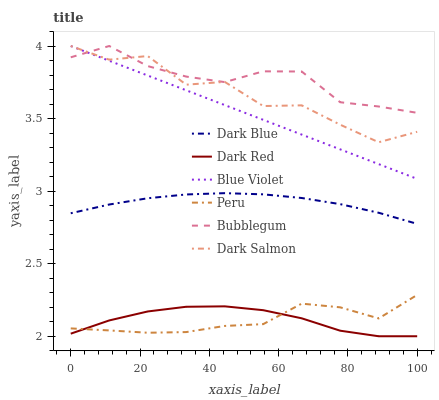Does Peru have the minimum area under the curve?
Answer yes or no. Yes. Does Bubblegum have the maximum area under the curve?
Answer yes or no. Yes. Does Dark Salmon have the minimum area under the curve?
Answer yes or no. No. Does Dark Salmon have the maximum area under the curve?
Answer yes or no. No. Is Blue Violet the smoothest?
Answer yes or no. Yes. Is Dark Salmon the roughest?
Answer yes or no. Yes. Is Bubblegum the smoothest?
Answer yes or no. No. Is Bubblegum the roughest?
Answer yes or no. No. Does Dark Red have the lowest value?
Answer yes or no. Yes. Does Dark Salmon have the lowest value?
Answer yes or no. No. Does Blue Violet have the highest value?
Answer yes or no. Yes. Does Dark Blue have the highest value?
Answer yes or no. No. Is Dark Red less than Blue Violet?
Answer yes or no. Yes. Is Blue Violet greater than Dark Red?
Answer yes or no. Yes. Does Dark Salmon intersect Blue Violet?
Answer yes or no. Yes. Is Dark Salmon less than Blue Violet?
Answer yes or no. No. Is Dark Salmon greater than Blue Violet?
Answer yes or no. No. Does Dark Red intersect Blue Violet?
Answer yes or no. No. 